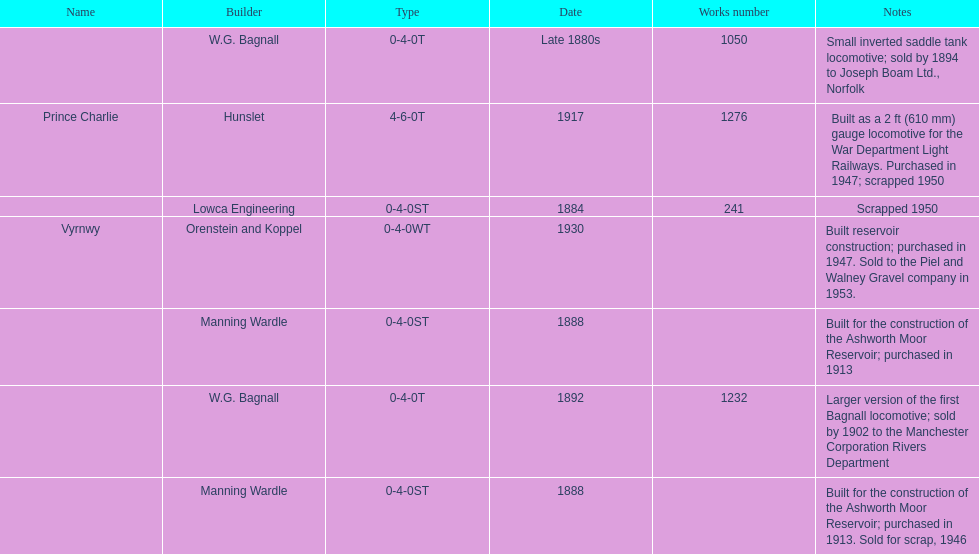How many locomotives were built before the 1900s? 5. 